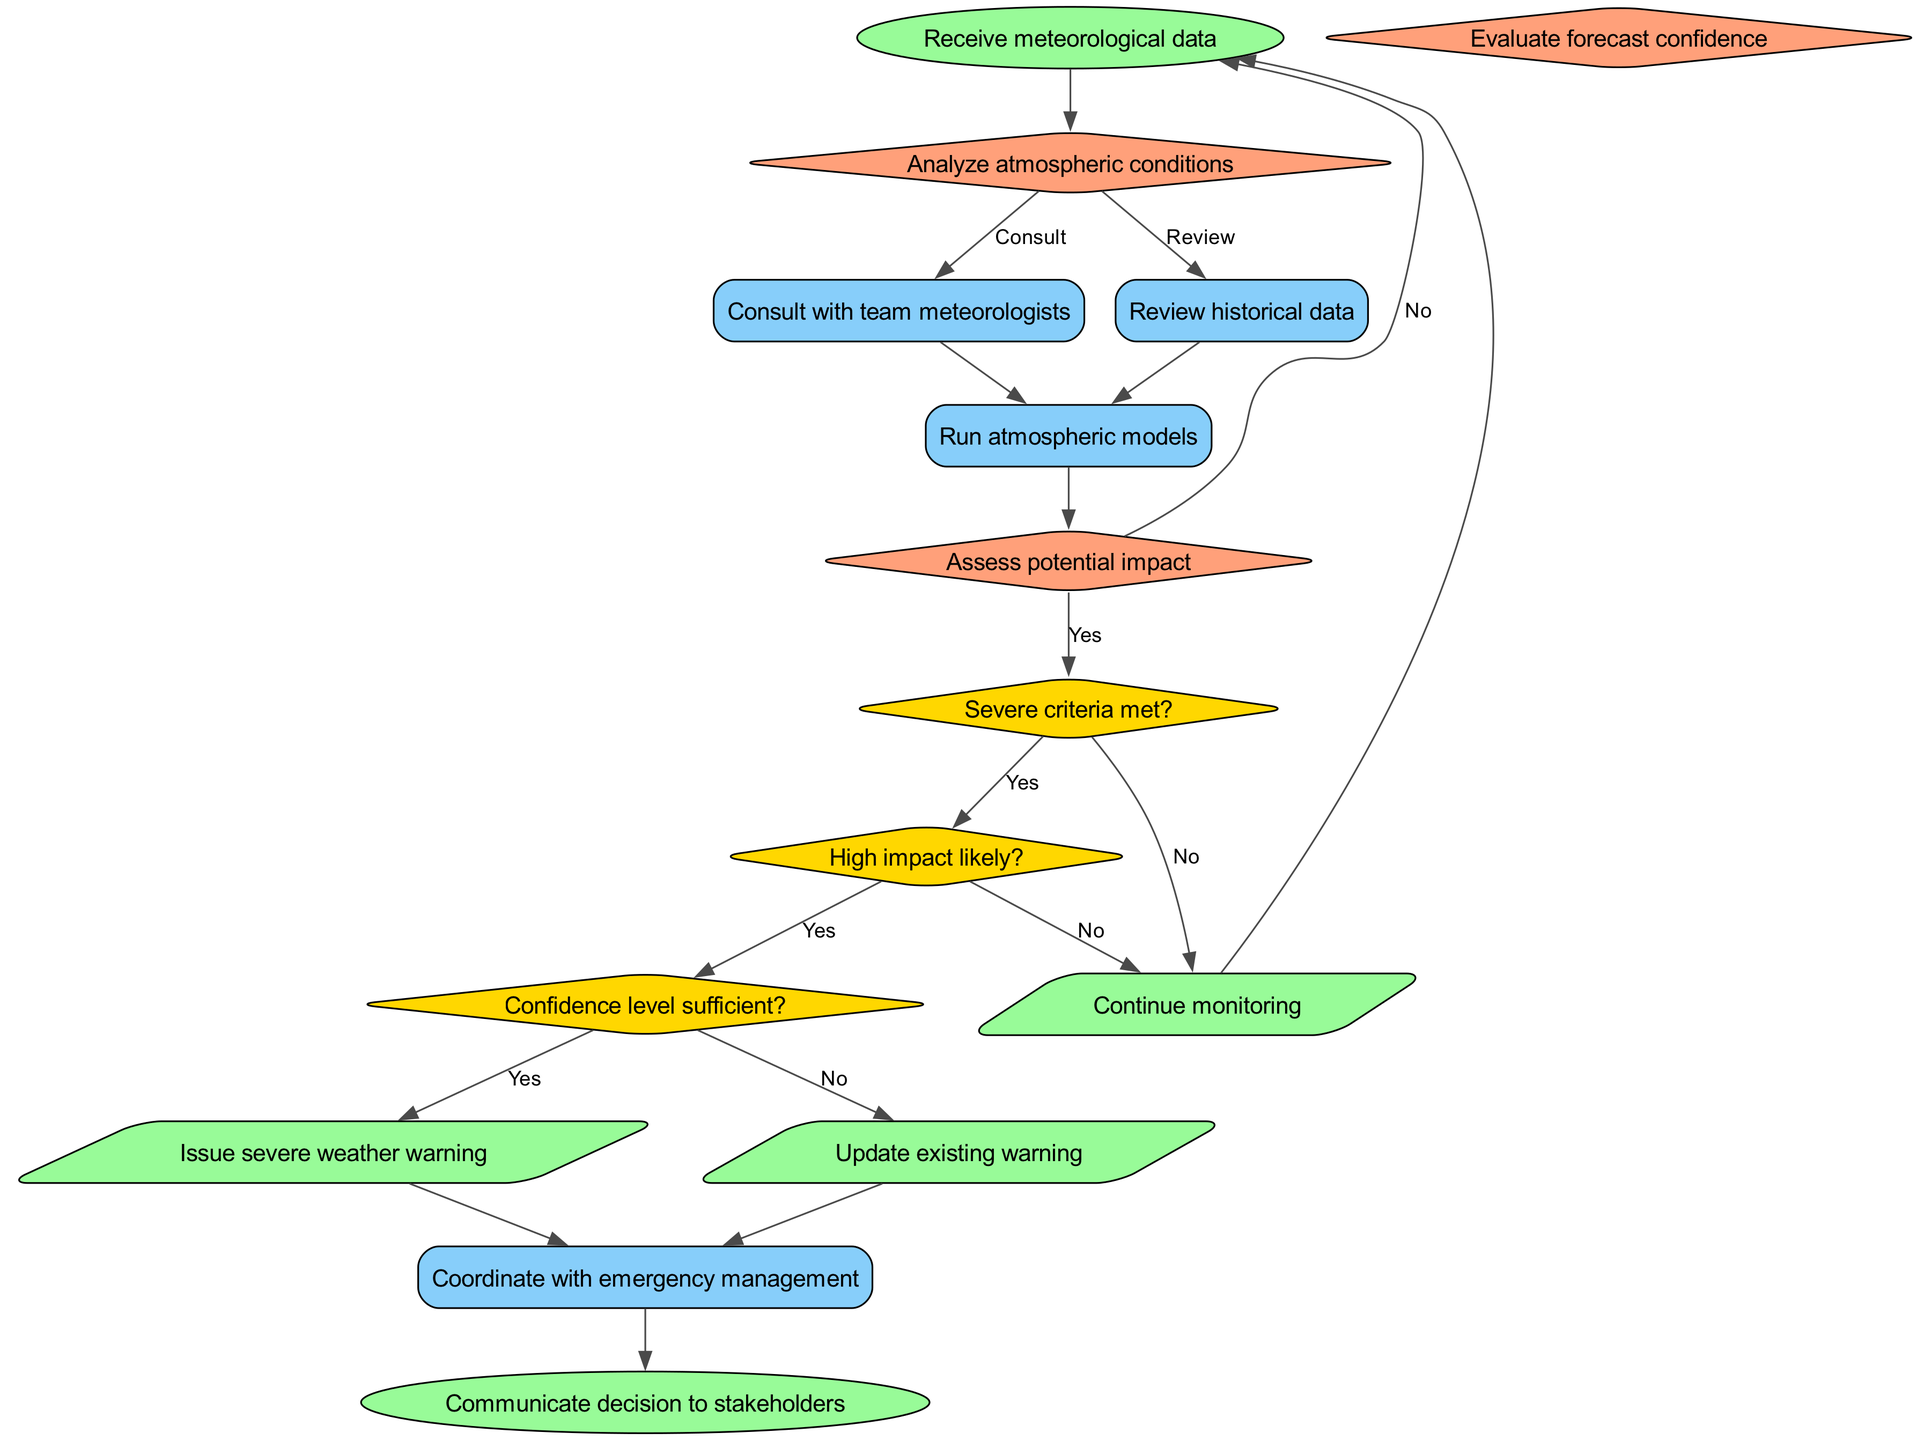What is the first step in the decision-making process? The first step, indicated by the start node, is "Receive meteorological data". This is where the process begins before any further analysis or decision-making occurs.
Answer: Receive meteorological data How many decision points are in the diagram? The diagram contains three decision points: "Analyze atmospheric conditions", "Assess potential impact", and "Evaluate forecast confidence". Therefore, the count is three.
Answer: 3 What action follows after consulting with team meteorologists? After consulting, the next action is to "Run atmospheric models". This is a direct flow from the consultation action to the atmospheric modeling action as shown in the diagram.
Answer: Run atmospheric models What condition must be met to issue a severe weather warning? The condition that must be met is "Severe criteria met?". If this condition holds true (yes), the flow proceeds towards the output "Issue severe weather warning".
Answer: Severe criteria met? What happens if confidence level is insufficient? If the confidence level is insufficient (no), the process outputs "Continue monitoring", indicating that no weather warnings will be issued at this point, and the monitoring continues until conditions change.
Answer: Continue monitoring What action occurs right after a severe weather warning is issued? Following the issuing of a severe weather warning, the next action is to "Coordinate with emergency management", indicating that a network with emergency services will be established for response efforts.
Answer: Coordinate with emergency management Which node represents the final step in the process? The final step is represented by the "Communicate decision to stakeholders" node, where the outcomes of the decision-making process are shared with relevant parties, ensuring that everyone is informed.
Answer: Communicate decision to stakeholders If the "Assess potential impact" decision yields a 'no' response, what is the next option? If the assessment of potential impact yields a 'no', the next option indicates a return to the "Receive meteorological data" step, indicating that further data or analysis may be needed before proceeding.
Answer: Receive meteorological data 